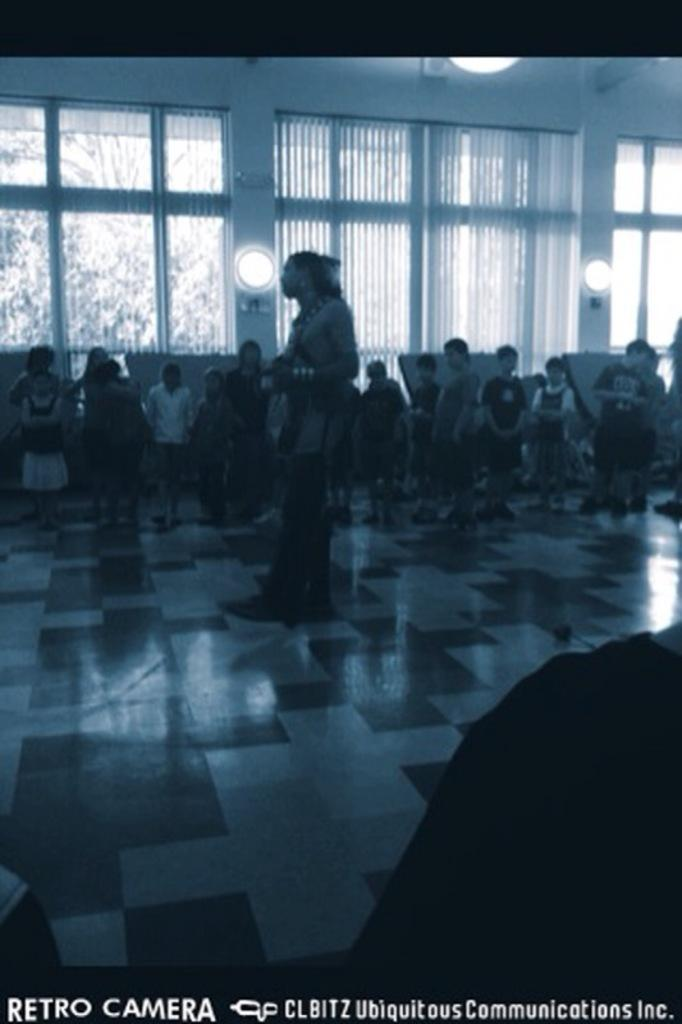What type of flooring is visible in the image? There are white and black color tiles in the image. Can you describe the people in the image? There are people in the image, but their specific characteristics are not mentioned in the facts. What is the purpose of the window in the image? The window allows for natural light and a view of the outdoors. What is associated with the window? There are curtains associated with the window. What type of lighting is present in the image? There are lights in the image. What can be seen outside the window? Trees are visible outside the window. What theory is being discussed by the people in the image? There is no information about a theory being discussed in the image. What type of straw is being used by the people in the image? There is no straw present in the image. 